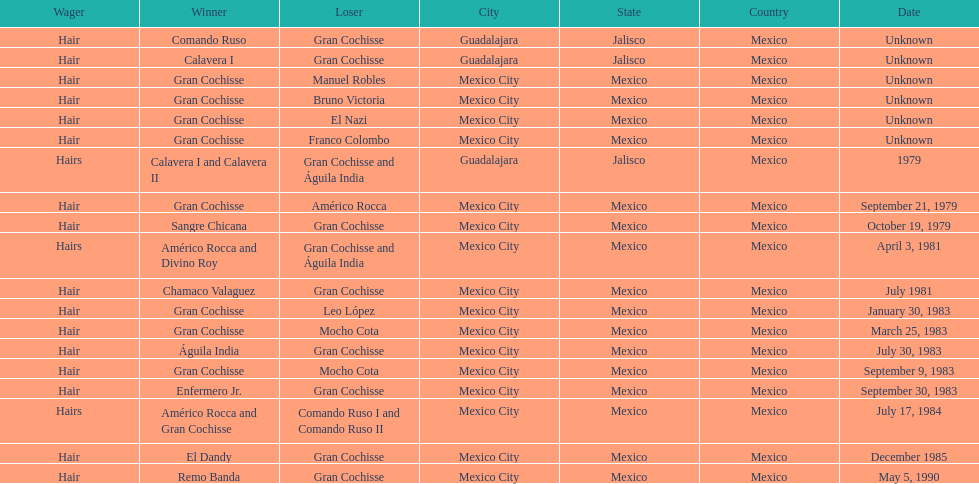How many winners were there before bruno victoria lost? 3. 